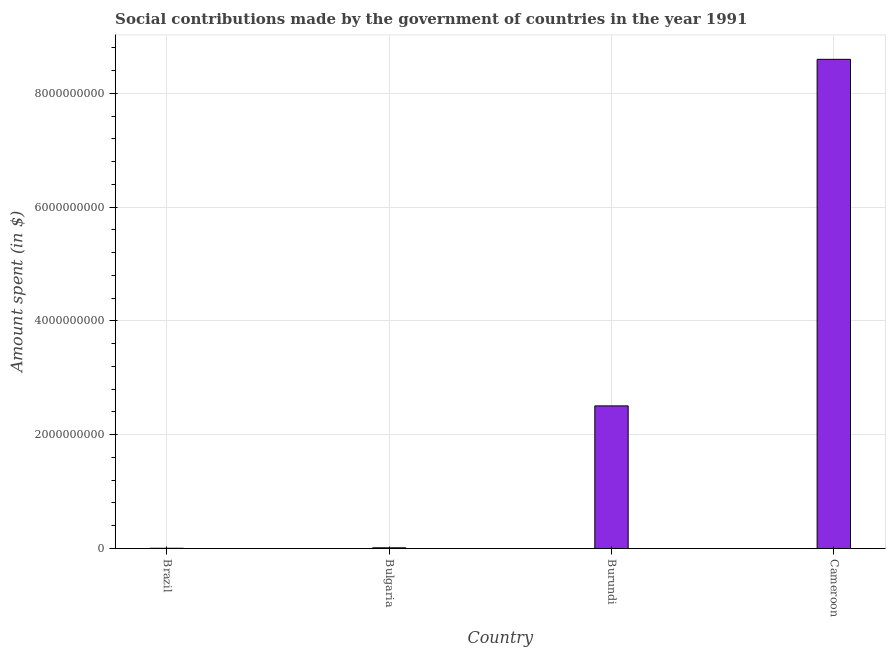Does the graph contain grids?
Provide a succinct answer. Yes. What is the title of the graph?
Ensure brevity in your answer.  Social contributions made by the government of countries in the year 1991. What is the label or title of the Y-axis?
Make the answer very short. Amount spent (in $). What is the amount spent in making social contributions in Cameroon?
Give a very brief answer. 8.60e+09. Across all countries, what is the maximum amount spent in making social contributions?
Your response must be concise. 8.60e+09. Across all countries, what is the minimum amount spent in making social contributions?
Offer a terse response. 3.83e+06. In which country was the amount spent in making social contributions maximum?
Keep it short and to the point. Cameroon. In which country was the amount spent in making social contributions minimum?
Ensure brevity in your answer.  Brazil. What is the sum of the amount spent in making social contributions?
Provide a succinct answer. 1.11e+1. What is the difference between the amount spent in making social contributions in Brazil and Bulgaria?
Your answer should be compact. -7.91e+06. What is the average amount spent in making social contributions per country?
Provide a short and direct response. 2.78e+09. What is the median amount spent in making social contributions?
Provide a short and direct response. 1.26e+09. What is the ratio of the amount spent in making social contributions in Bulgaria to that in Burundi?
Your answer should be compact. 0.01. Is the amount spent in making social contributions in Brazil less than that in Bulgaria?
Keep it short and to the point. Yes. What is the difference between the highest and the second highest amount spent in making social contributions?
Offer a very short reply. 6.09e+09. Is the sum of the amount spent in making social contributions in Brazil and Bulgaria greater than the maximum amount spent in making social contributions across all countries?
Your answer should be compact. No. What is the difference between the highest and the lowest amount spent in making social contributions?
Your answer should be very brief. 8.60e+09. How many bars are there?
Offer a very short reply. 4. How many countries are there in the graph?
Offer a terse response. 4. What is the difference between two consecutive major ticks on the Y-axis?
Your response must be concise. 2.00e+09. What is the Amount spent (in $) of Brazil?
Make the answer very short. 3.83e+06. What is the Amount spent (in $) in Bulgaria?
Your answer should be very brief. 1.17e+07. What is the Amount spent (in $) of Burundi?
Your answer should be compact. 2.51e+09. What is the Amount spent (in $) in Cameroon?
Your answer should be compact. 8.60e+09. What is the difference between the Amount spent (in $) in Brazil and Bulgaria?
Make the answer very short. -7.91e+06. What is the difference between the Amount spent (in $) in Brazil and Burundi?
Provide a short and direct response. -2.50e+09. What is the difference between the Amount spent (in $) in Brazil and Cameroon?
Your answer should be compact. -8.60e+09. What is the difference between the Amount spent (in $) in Bulgaria and Burundi?
Make the answer very short. -2.50e+09. What is the difference between the Amount spent (in $) in Bulgaria and Cameroon?
Your response must be concise. -8.59e+09. What is the difference between the Amount spent (in $) in Burundi and Cameroon?
Your answer should be compact. -6.09e+09. What is the ratio of the Amount spent (in $) in Brazil to that in Bulgaria?
Offer a very short reply. 0.33. What is the ratio of the Amount spent (in $) in Brazil to that in Burundi?
Keep it short and to the point. 0. What is the ratio of the Amount spent (in $) in Bulgaria to that in Burundi?
Your response must be concise. 0.01. What is the ratio of the Amount spent (in $) in Bulgaria to that in Cameroon?
Ensure brevity in your answer.  0. What is the ratio of the Amount spent (in $) in Burundi to that in Cameroon?
Your answer should be compact. 0.29. 